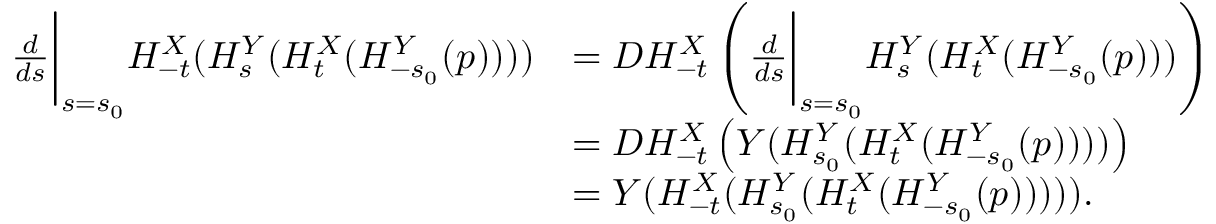Convert formula to latex. <formula><loc_0><loc_0><loc_500><loc_500>\begin{array} { r l } { \frac { d } { d s } \left | _ { s = s _ { 0 } } H _ { - t } ^ { X } ( H _ { s } ^ { Y } ( H _ { t } ^ { X } ( H _ { - s _ { 0 } } ^ { Y } ( p ) ) ) ) } & { = D H _ { - t } ^ { X } \left ( \frac { d } { d s } \right | _ { s = s _ { 0 } } H _ { s } ^ { Y } ( H _ { t } ^ { X } ( H _ { - s _ { 0 } } ^ { Y } ( p ) ) ) \right ) } \\ & { = D H _ { - t } ^ { X } \left ( Y ( H _ { s _ { 0 } } ^ { Y } ( H _ { t } ^ { X } ( H _ { - s _ { 0 } } ^ { Y } ( p ) ) ) ) \right ) } \\ & { = Y ( H _ { - t } ^ { X } ( H _ { s _ { 0 } } ^ { Y } ( H _ { t } ^ { X } ( H _ { - s _ { 0 } } ^ { Y } ( p ) ) ) ) ) . } \end{array}</formula> 